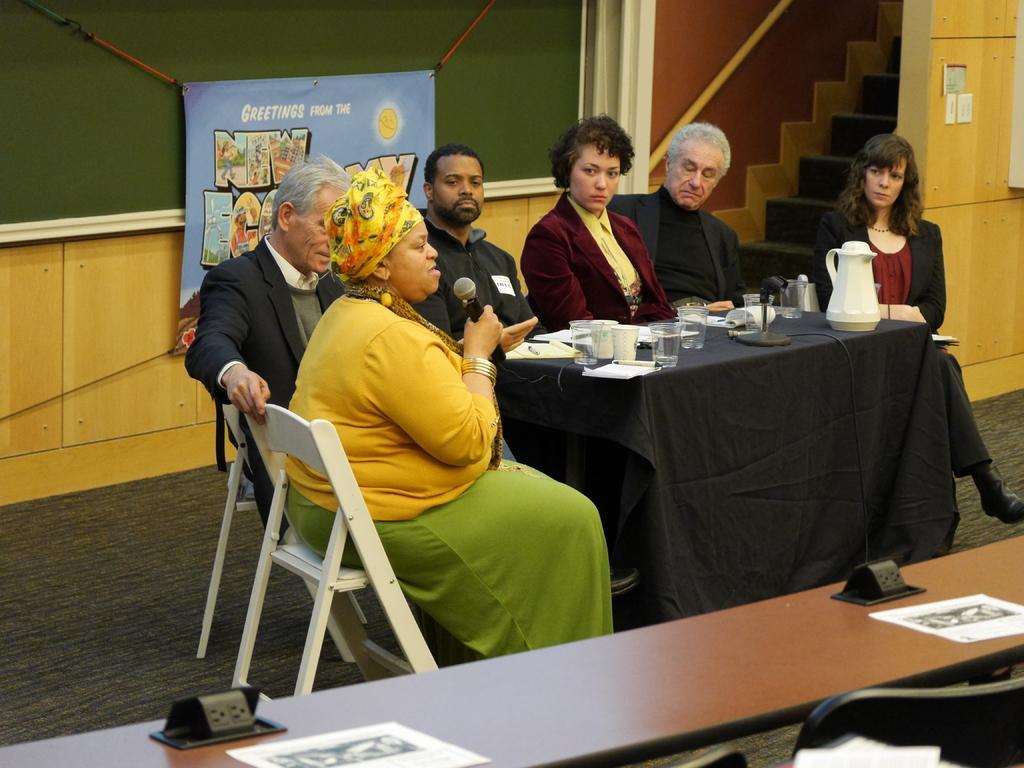How would you summarize this image in a sentence or two? On the background we can see a banner, board, stairs and a socket. We can see persons sitting on chairs sitting on chairs in front of a table and on the table we can see a jar, water glasses, pen , books and paper. We can see this woman holding a mike in her hand and talking. This is a floor. 